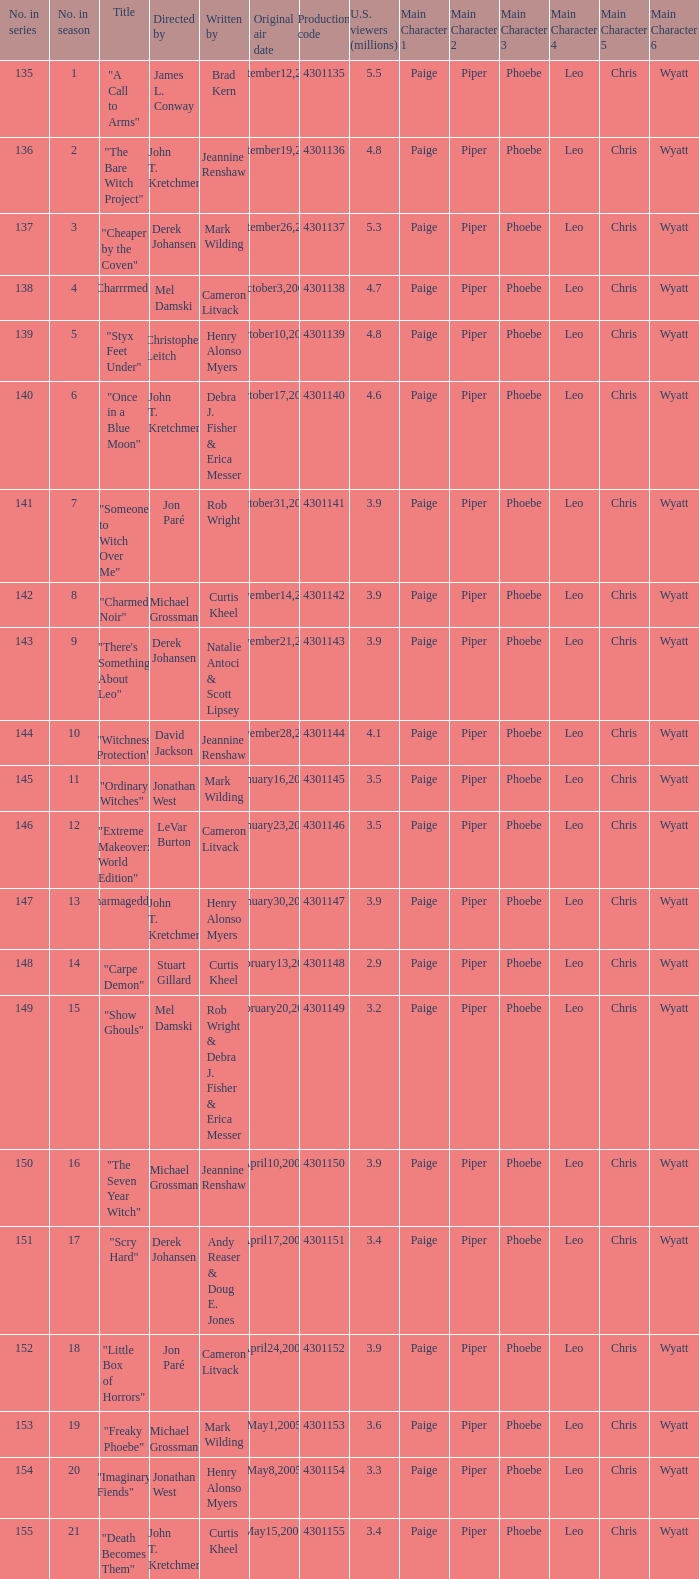What was the name of the episode that got 3.3 (millions) of u.s viewers? "Imaginary Fiends". 